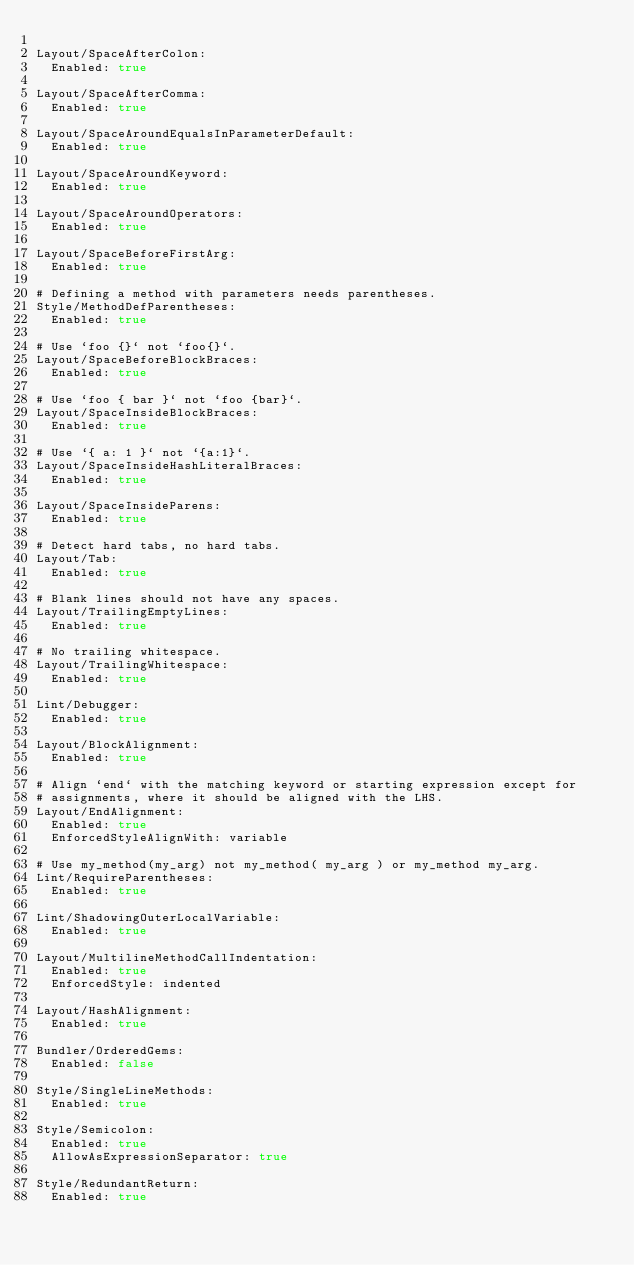Convert code to text. <code><loc_0><loc_0><loc_500><loc_500><_YAML_>
Layout/SpaceAfterColon:
  Enabled: true

Layout/SpaceAfterComma:
  Enabled: true

Layout/SpaceAroundEqualsInParameterDefault:
  Enabled: true

Layout/SpaceAroundKeyword:
  Enabled: true

Layout/SpaceAroundOperators:
  Enabled: true

Layout/SpaceBeforeFirstArg:
  Enabled: true

# Defining a method with parameters needs parentheses.
Style/MethodDefParentheses:
  Enabled: true

# Use `foo {}` not `foo{}`.
Layout/SpaceBeforeBlockBraces:
  Enabled: true

# Use `foo { bar }` not `foo {bar}`.
Layout/SpaceInsideBlockBraces:
  Enabled: true

# Use `{ a: 1 }` not `{a:1}`.
Layout/SpaceInsideHashLiteralBraces:
  Enabled: true

Layout/SpaceInsideParens:
  Enabled: true

# Detect hard tabs, no hard tabs.
Layout/Tab:
  Enabled: true

# Blank lines should not have any spaces.
Layout/TrailingEmptyLines:
  Enabled: true

# No trailing whitespace.
Layout/TrailingWhitespace:
  Enabled: true

Lint/Debugger:
  Enabled: true

Layout/BlockAlignment:
  Enabled: true

# Align `end` with the matching keyword or starting expression except for
# assignments, where it should be aligned with the LHS.
Layout/EndAlignment:
  Enabled: true
  EnforcedStyleAlignWith: variable

# Use my_method(my_arg) not my_method( my_arg ) or my_method my_arg.
Lint/RequireParentheses:
  Enabled: true

Lint/ShadowingOuterLocalVariable:
  Enabled: true

Layout/MultilineMethodCallIndentation:
  Enabled: true
  EnforcedStyle: indented

Layout/HashAlignment:
  Enabled: true

Bundler/OrderedGems:
  Enabled: false

Style/SingleLineMethods:
  Enabled: true

Style/Semicolon:
  Enabled: true
  AllowAsExpressionSeparator: true

Style/RedundantReturn:
  Enabled: true
</code> 